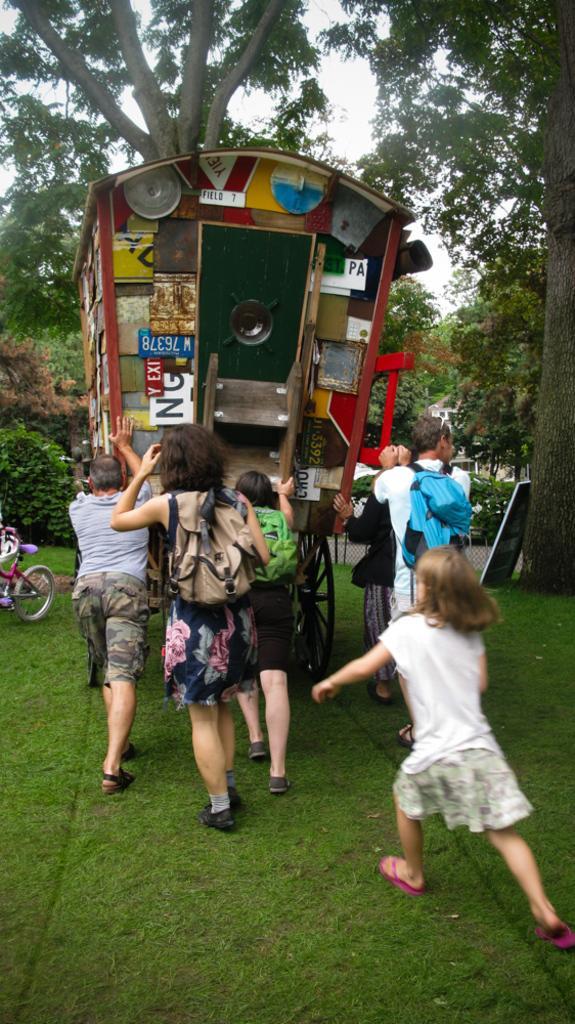How would you summarize this image in a sentence or two? In this picture we can see some people pushing a vehicle. These are the plants and trees. Here we can see one bicycle. This is the grass. And there is a sky. 